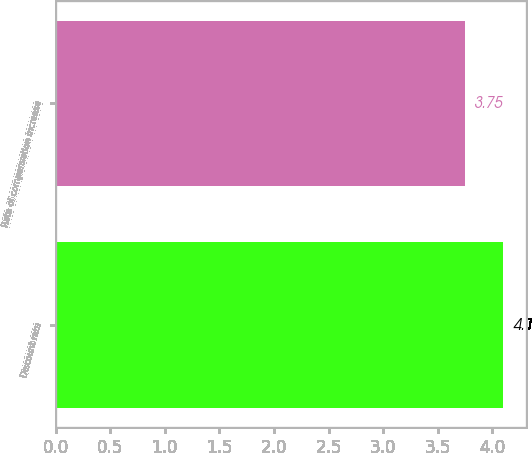Convert chart. <chart><loc_0><loc_0><loc_500><loc_500><bar_chart><fcel>Discount rate<fcel>Rate of compensation increase<nl><fcel>4.1<fcel>3.75<nl></chart> 